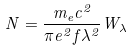<formula> <loc_0><loc_0><loc_500><loc_500>N = \frac { m _ { e } c ^ { 2 } } { \pi e ^ { 2 } f \lambda ^ { 2 } } W _ { \lambda }</formula> 